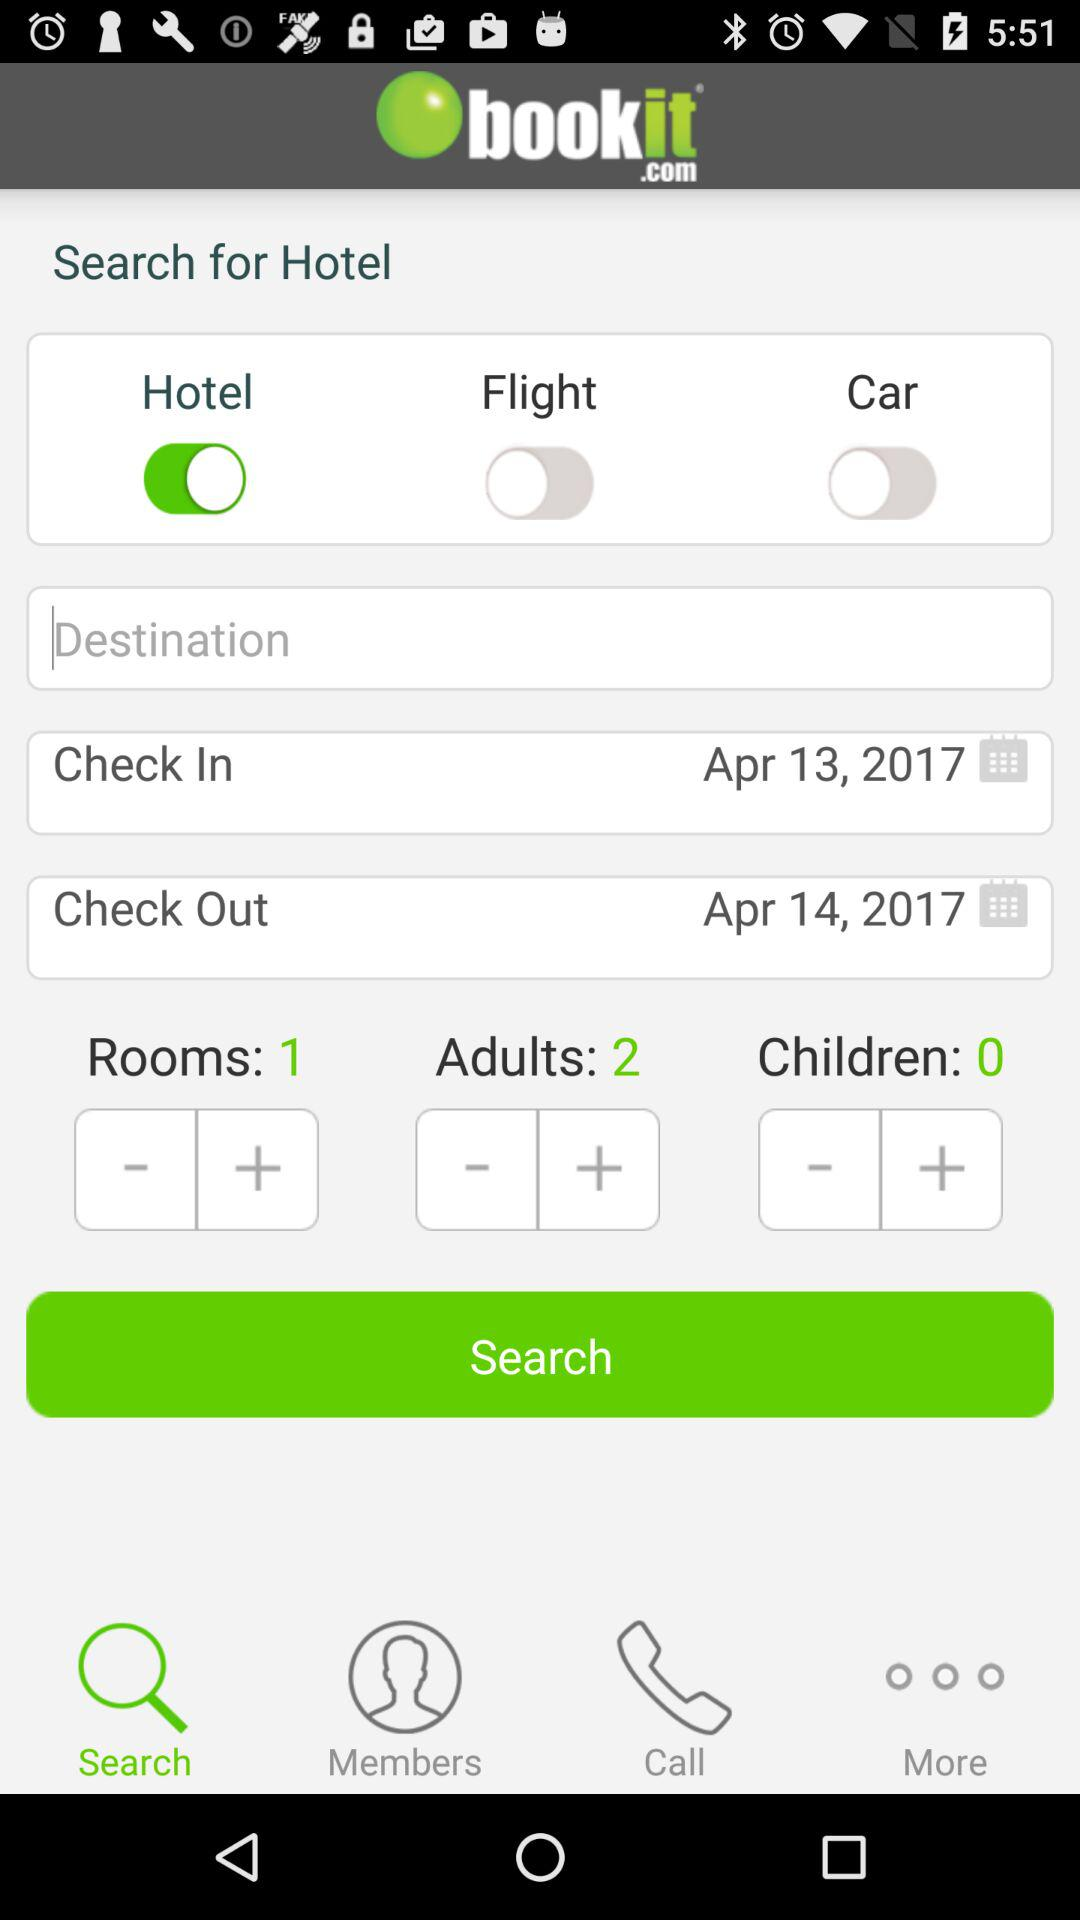How many rooms are there? There is 1 room. 